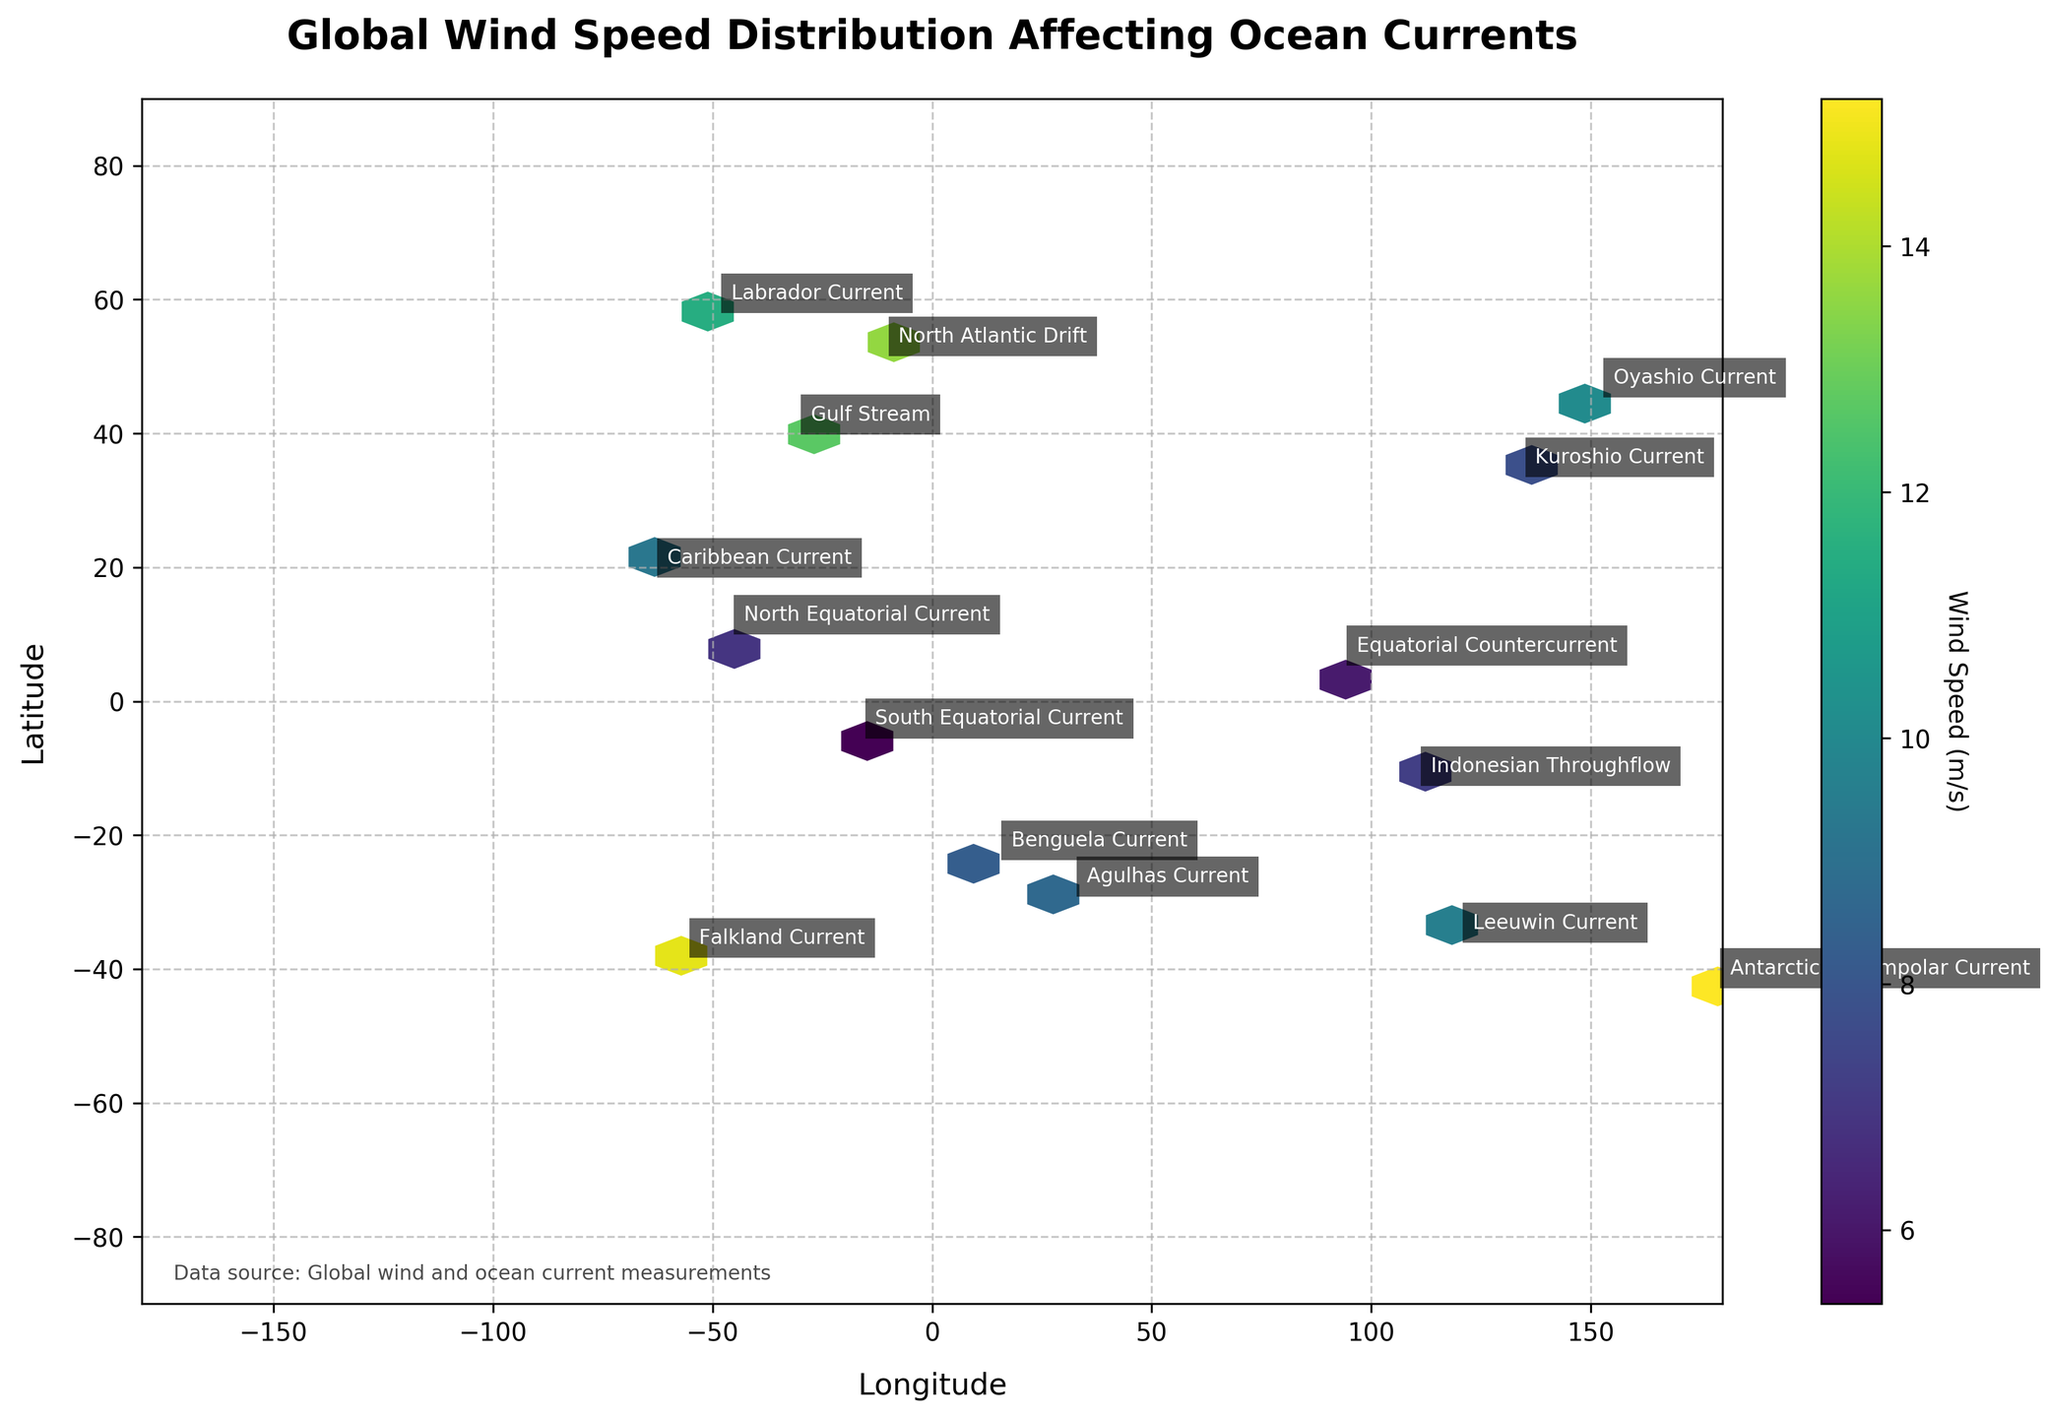What is the title of the figure? The title is usually located at the top of the figure and provides an overview of what the data represents.
Answer: Global Wind Speed Distribution Affecting Ocean Currents What are the x and y-axis labels? The axis labels are typically found next to the respective axes and indicate what the axes represent.
Answer: Longitude (x-axis), Latitude (y-axis) Which ocean current is annotated at approximately (45.6, 152.3)? Look for the annotation text near the specified coordinates.
Answer: Oyashio Current What is the wind speed range indicated by the color bar? The color bar provides a visual legend for the wind speeds represented by different colors.
Answer: 5.4 to 15.2 m/s Which region has the highest density of data points? Density is represented by the color intensity in a hexbin plot. The region with the darkest color will have the highest density of data points.
Answer: The region around (51.8, -10.5) Which ocean current experiences the highest wind speed, and what is the value? Identify the ocean current and match it with the highest value on the color bar. Check the data points if needed.
Answer: Antarctic Circumpolar Current, 15.2 m/s Compare the wind speed of the Benguela Current and the Caribbean Current. Which one is higher? Locate the respective points and compare their color intensity based on the color bar.
Answer: Benguela Current What is the average latitude of the currents displayed in the figure? Calculate the sum of the latitudes of all points and divide by the number of points.
Answer: (−23.5 + 40.1 + −35.8 + 10.2 + −42.6 + 33.7 + −5.3 + 58.2 + −28.9 + 45.6 + 18.7 + −12.4 + 51.8 + −38.1 + 5.6) / 15 = 5.49 Which ocean current closest to the equator has the highest wind speed? Identify the currents near the equator (latitude close to 0) and compare their wind speeds.
Answer: South Equatorial Current How are the Agulhas Current and the Falkland Current distributed in terms of wind direction? Find the annotations for these currents and check their corresponding wind direction from the dataset.
Answer: NE for Agulhas Current, NW for Falkland Current 